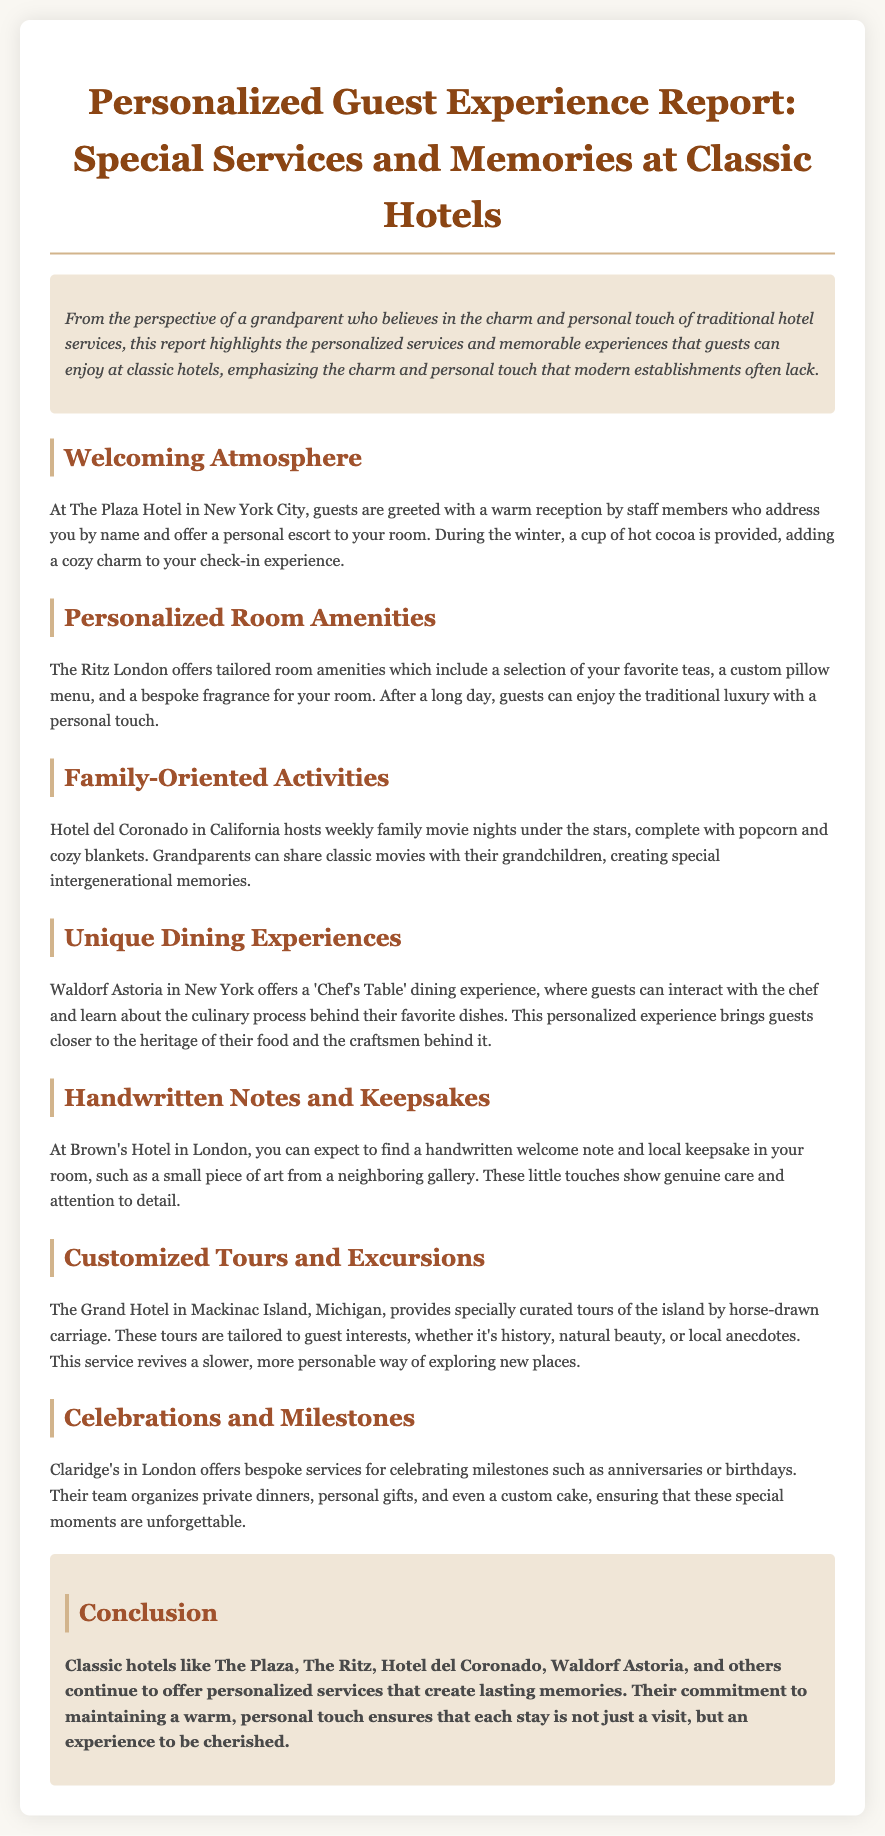What special beverage is provided at check-in? The document states that during the winter, guests receive a cup of hot cocoa at check-in, adding a cozy charm.
Answer: hot cocoa What amenity is tailored at The Ritz London? The Ritz London offers a custom pillow menu as part of their tailored room amenities.
Answer: custom pillow menu What type of event does Hotel del Coronado host weekly? The hotel is noted for hosting family movie nights under the stars, creating memories for guests.
Answer: family movie nights What unique dining experience is offered at Waldorf Astoria? The document highlights the 'Chef's Table' dining experience where guests can interact with the chef.
Answer: Chef's Table What type of note can guests expect at Brown's Hotel? Guests can expect to find a handwritten welcome note in their room, reflecting the hotel's personal touch.
Answer: handwritten welcome note What is a feature of the tours offered by The Grand Hotel? The Grand Hotel provides specially curated tours which are tailored to guest interests, enhancing the exploration experience.
Answer: tailored to guest interests What type of services does Claridge's offer for special occasions? Claridge's specializes in bespoke services for celebrating milestones, such as anniversaries or birthdays.
Answer: bespoke services How do classic hotels like The Plaza and The Ritz ensure memorable stays? The conclusion emphasizes that these hotels maintain a warm, personal touch to create lasting memories for their guests.
Answer: warm, personal touch 